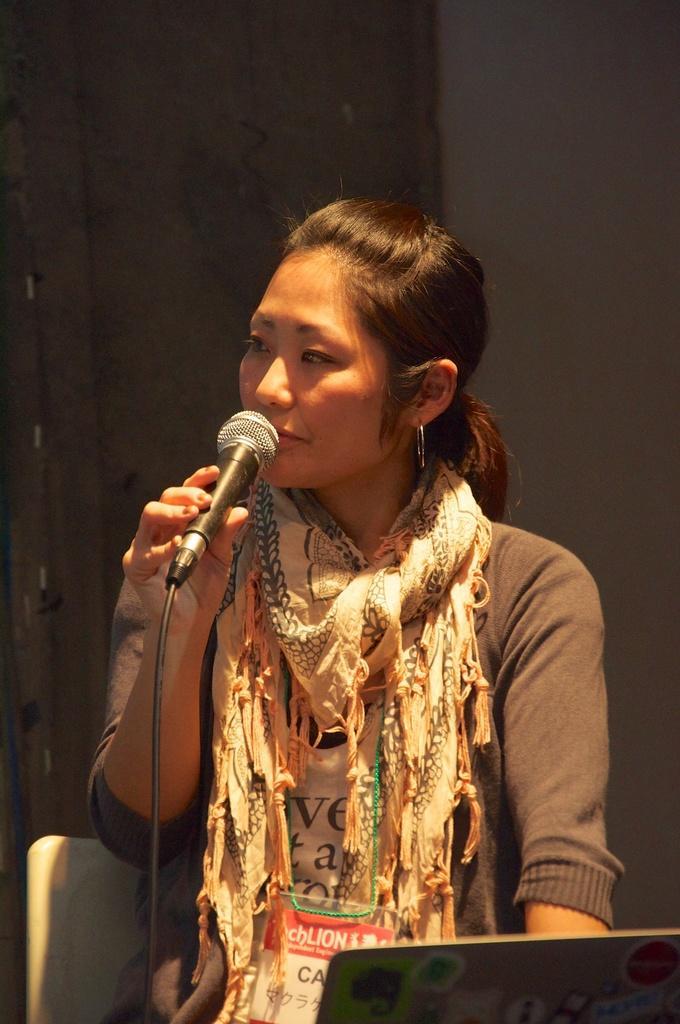Could you give a brief overview of what you see in this image? This is the picture of a woman, the woman is holding a microphone. The woman is sitting on a chair. background of this woman is a wall. The woman is wearing a scarf. 